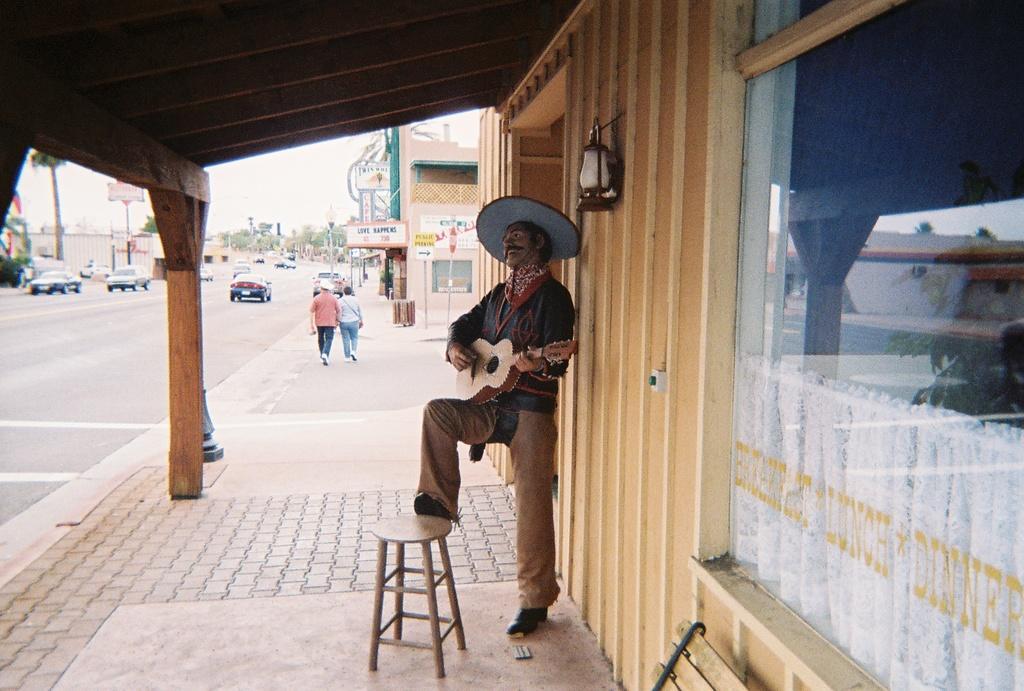How would you summarize this image in a sentence or two? In this image we can see a person with a hat playing a guitar and standing under the building roof. Image also consists of many vehicles, trees and buildings. We can see a road on the left. Sky is also visible. There is also a chair on the ground. 